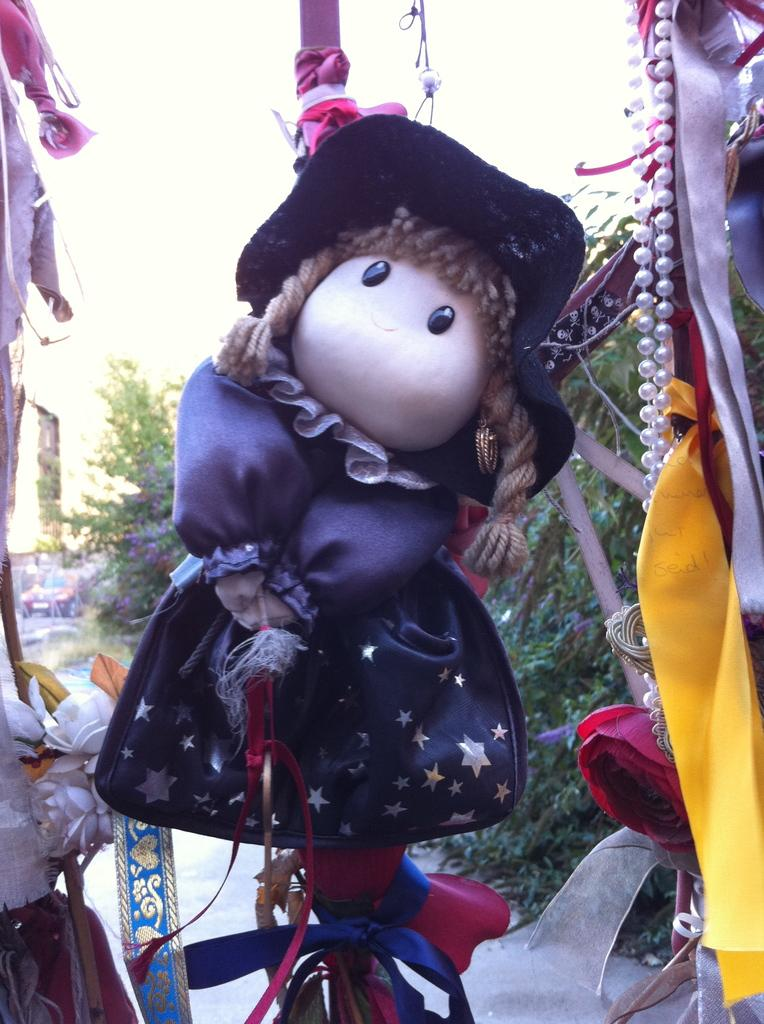What is the main subject in the center of the image? There is a toy in the center of the image. What can be seen in the background of the image? There are trees in the background of the image. What is visible at the top of the image? The sky is visible at the top of the image. Are there any representatives of the bear or tiger species present in the image? No, there are no bears or tigers present in the image. 